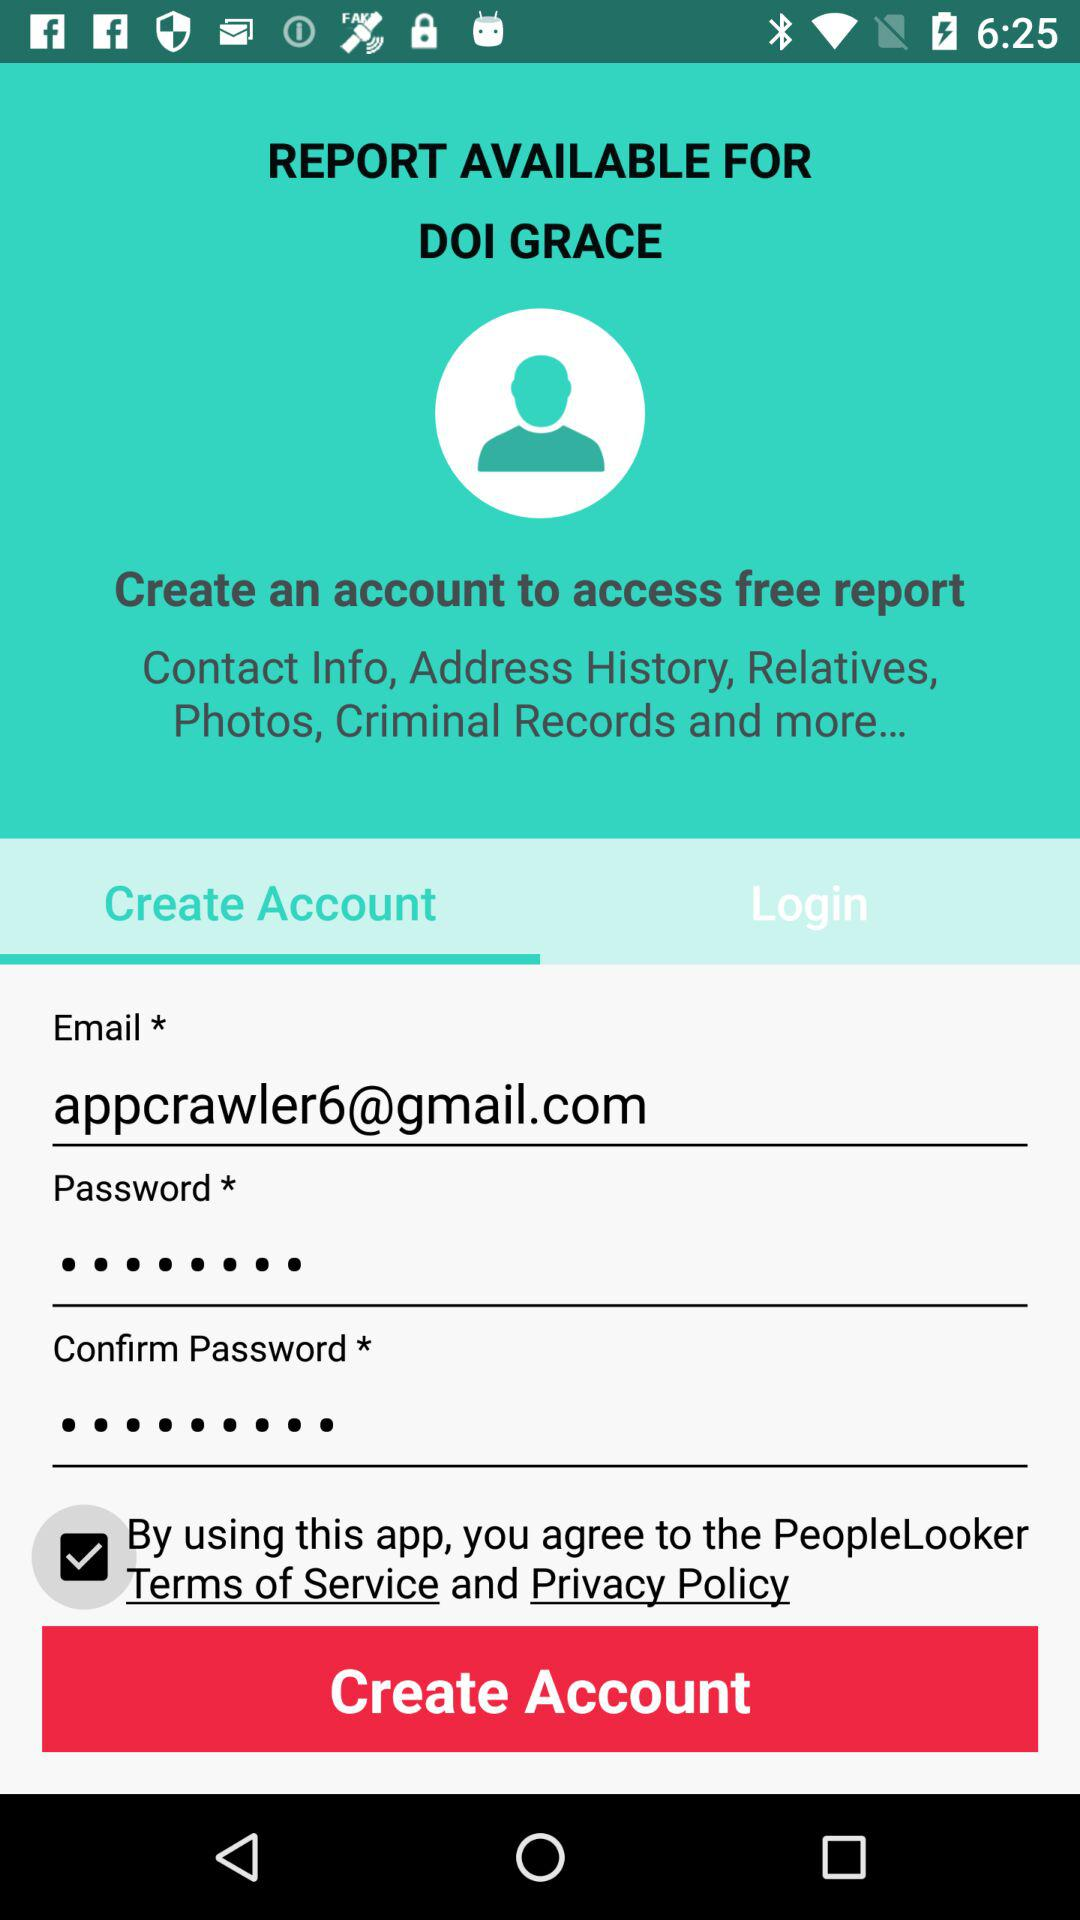Which tab has been selected? The selected tab is "Create Account". 